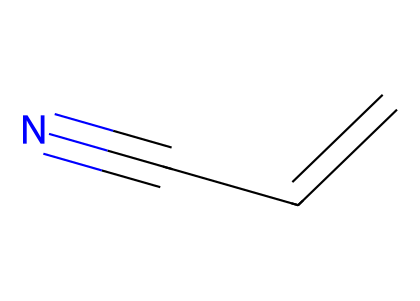What is the molecular formula of acrylonitrile? To determine the molecular formula, count the carbon (C), hydrogen (H), and nitrogen (N) atoms present in the SMILES representation. The structure C=CC#N shows that there are 3 carbon atoms, 3 hydrogen atoms, and 1 nitrogen atom, resulting in the molecular formula C3H3N.
Answer: C3H3N How many double bonds are present in acrylonitrile? Inspect the structure for double bonds. The SMILES representation C=CC#N indicates there is one double bond between the first two carbon atoms.
Answer: 1 What type of functional group is present in acrylonitrile? Analyze the functional groups in the structure. The presence of the cyano group (-C≡N) indicates the nitrile functional group is present in this compound.
Answer: nitrile What is the significance of the cyano group in acrylonitrile? Understanding the nitrile group leads us to its chemical properties, such as its reactivity, ability to polymerize, and its role as a precursor for synthetic fibers. The cyano group contributes to acrylonitrile's industrial applications.
Answer: precursor How many total bonds are present in acrylonitrile? Count all bonds in the structure. From the C=C double bond and the C#N triple bond, combined with single bonds between carbons and hydrogens, the total bond count is 5 (1 double bond and 1 triple bond contribute more than one to the count).
Answer: 5 What determines the polarity of acrylonitrile? Assess the electronegativity of the involved atoms. The presence of a highly electronegative nitrogen atom in the cyano group leads to a polar molecule due to the difference in electronegativity between carbon and nitrogen, contributing to its overall polarity.
Answer: polar 